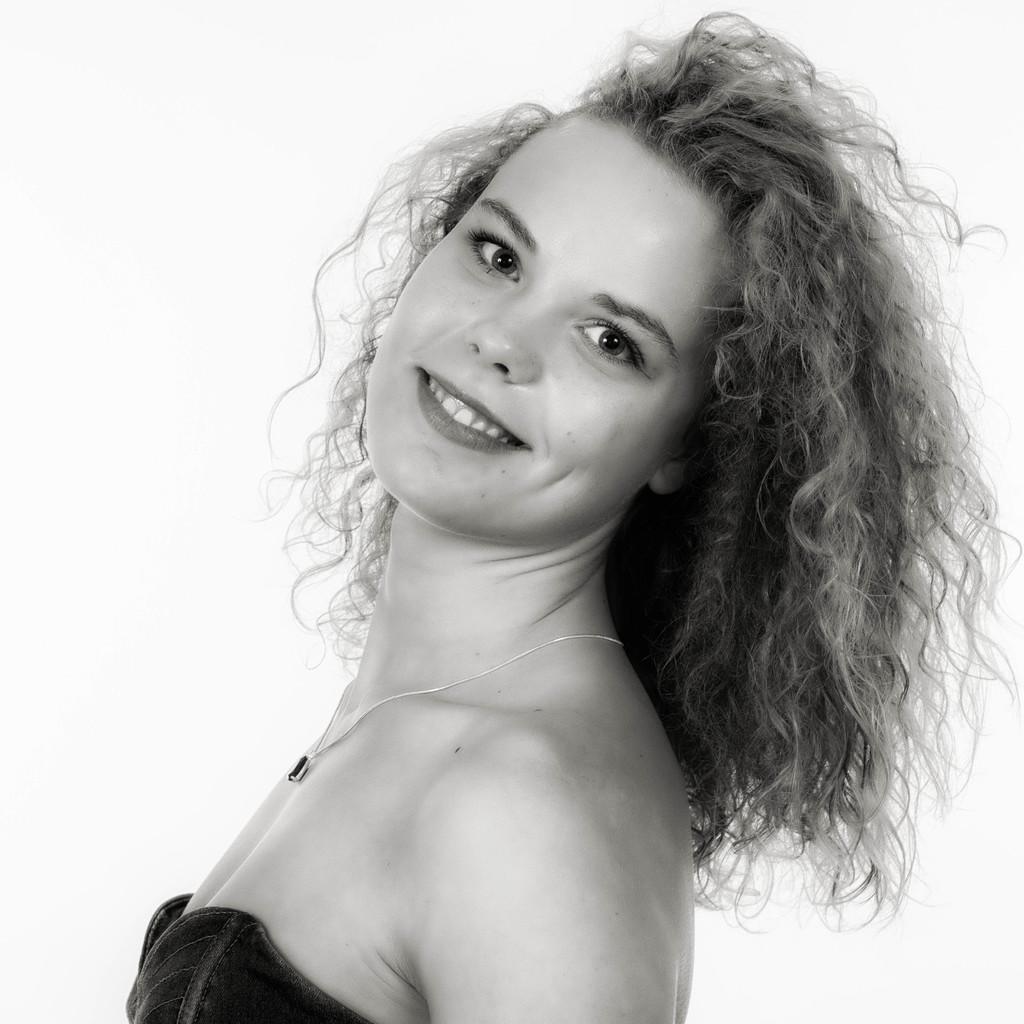Please provide a concise description of this image. In this image I can see a person standing and the person is wearing a chain, and the image is in black and white. 